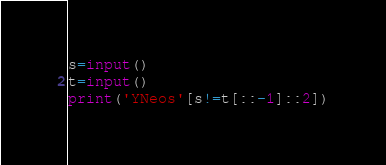<code> <loc_0><loc_0><loc_500><loc_500><_Python_>s=input()
t=input()
print('YNeos'[s!=t[::-1]::2])</code> 